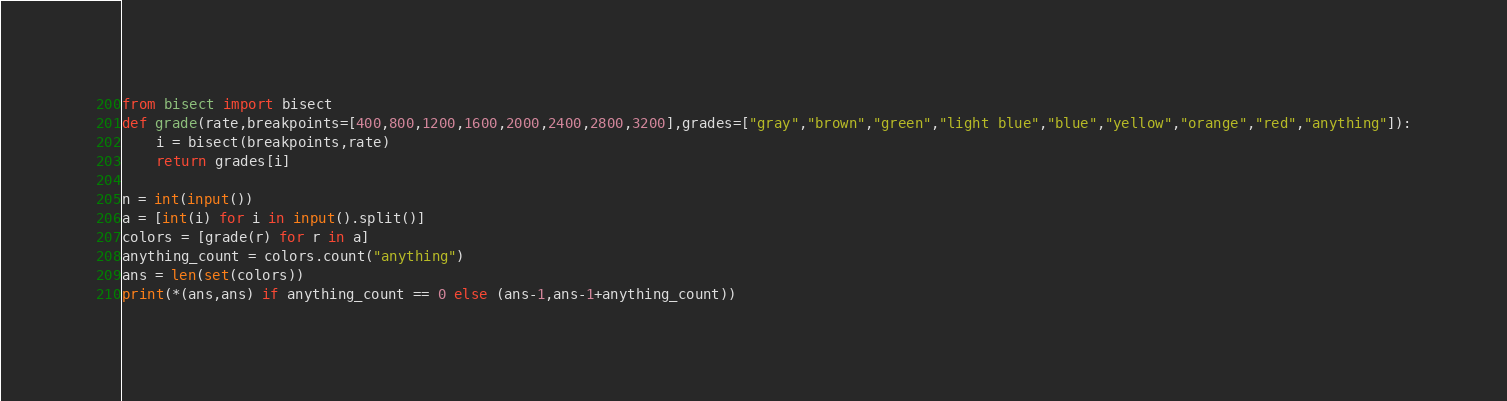Convert code to text. <code><loc_0><loc_0><loc_500><loc_500><_Python_>from bisect import bisect
def grade(rate,breakpoints=[400,800,1200,1600,2000,2400,2800,3200],grades=["gray","brown","green","light blue","blue","yellow","orange","red","anything"]):
    i = bisect(breakpoints,rate)
    return grades[i]

n = int(input())
a = [int(i) for i in input().split()]
colors = [grade(r) for r in a]
anything_count = colors.count("anything")
ans = len(set(colors))
print(*(ans,ans) if anything_count == 0 else (ans-1,ans-1+anything_count))</code> 